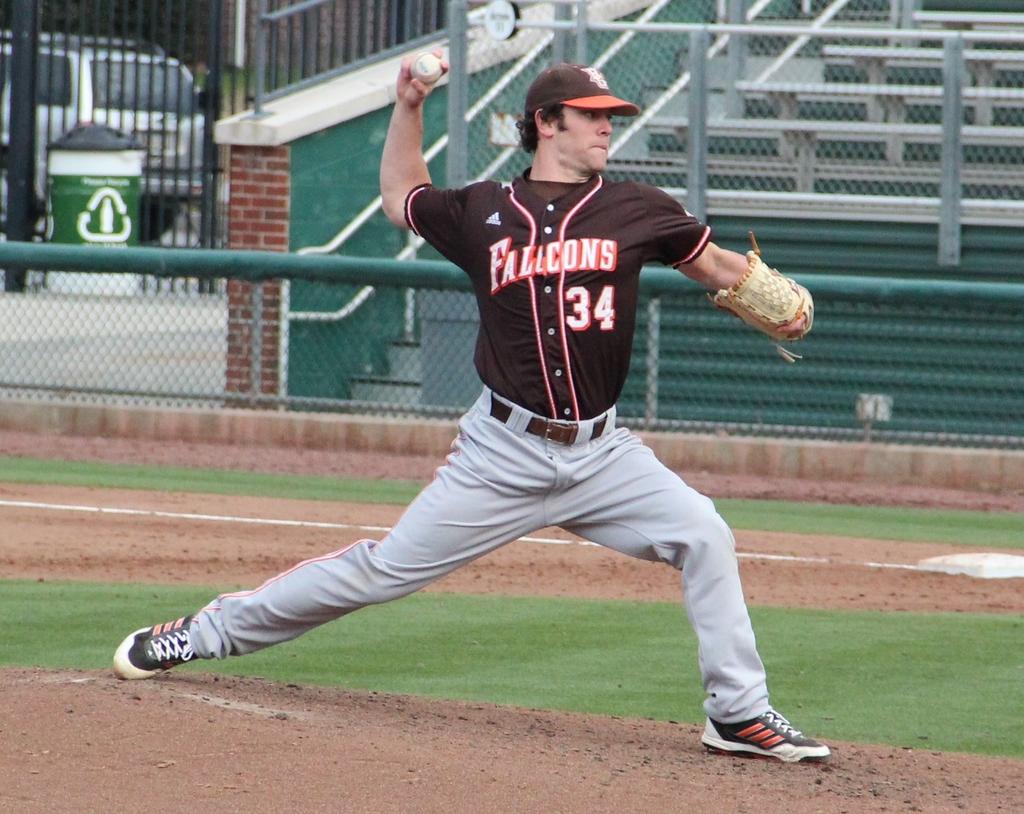Which team does the player play for?
Provide a succinct answer. Falcons. 